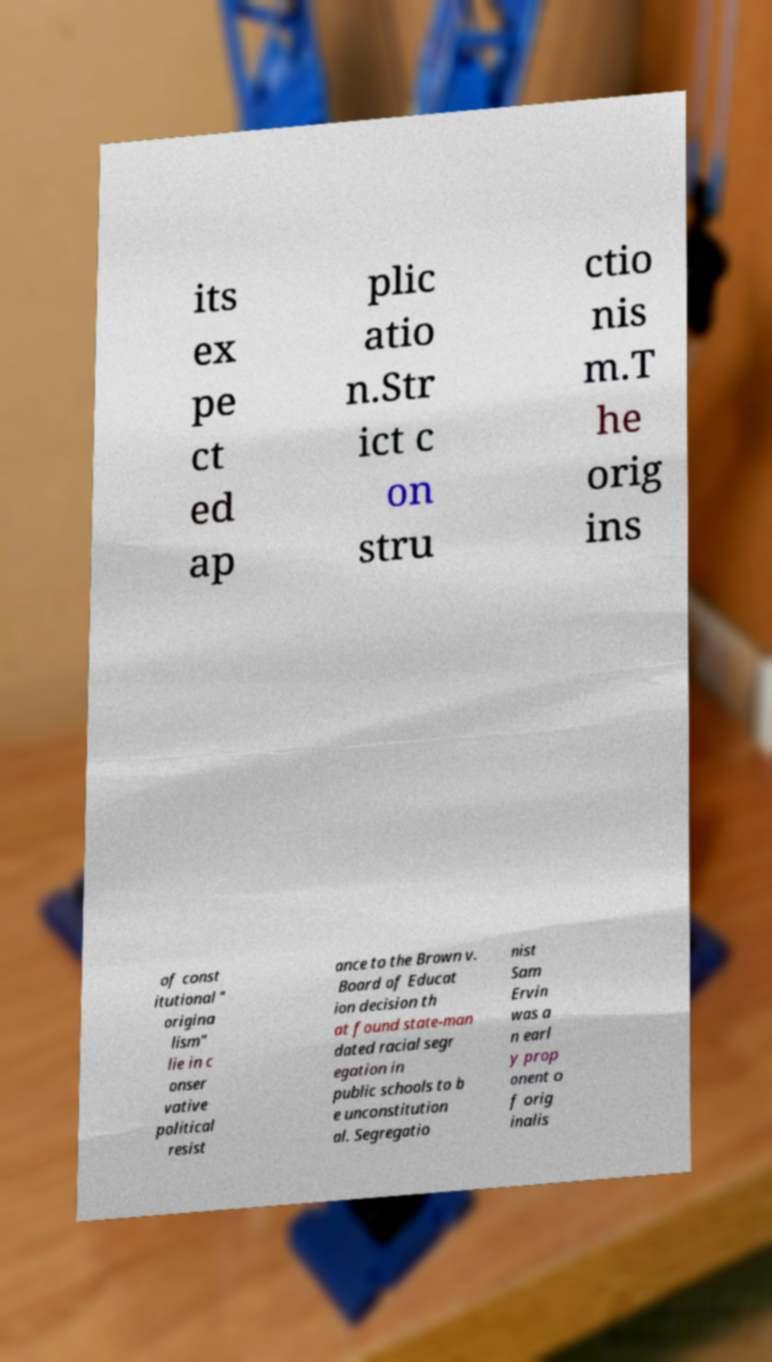Could you assist in decoding the text presented in this image and type it out clearly? its ex pe ct ed ap plic atio n.Str ict c on stru ctio nis m.T he orig ins of const itutional " origina lism" lie in c onser vative political resist ance to the Brown v. Board of Educat ion decision th at found state-man dated racial segr egation in public schools to b e unconstitution al. Segregatio nist Sam Ervin was a n earl y prop onent o f orig inalis 